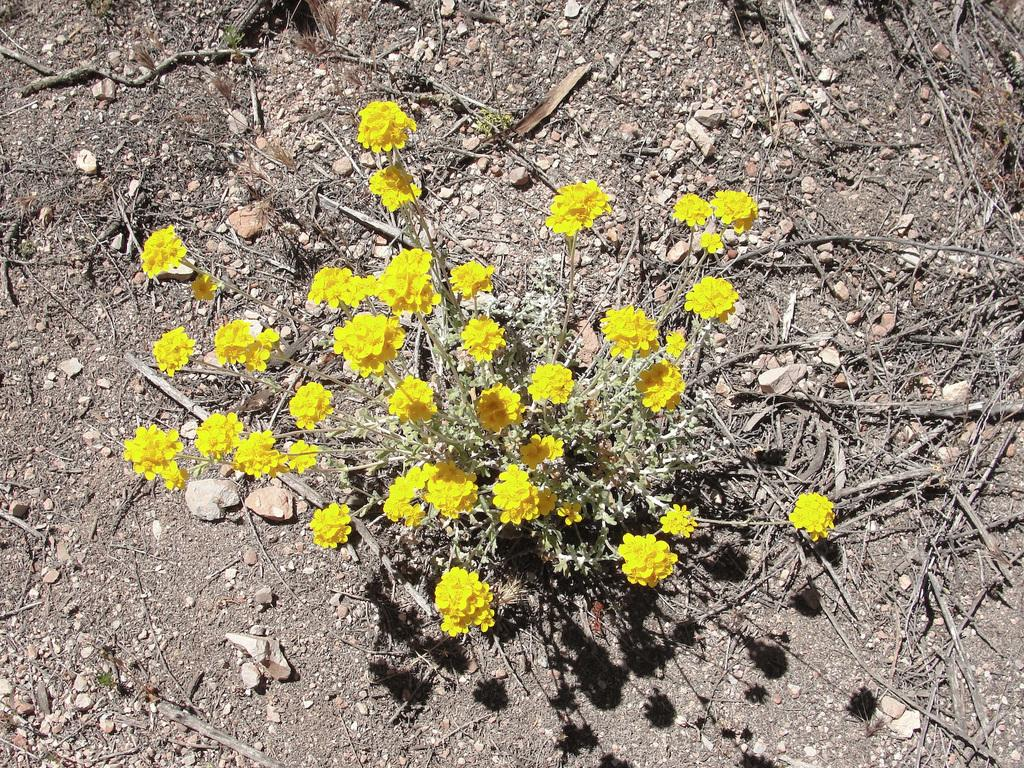What type of plant can be seen in the image? There is a yellow flower plant in the image. What else is present in the image besides the plant? There are branches and rocks in the image. What type of wine is being served in the image? There is no wine present in the image; it features a yellow flower plant, branches, and rocks. Can you see the father in the image? There is no person, including a father, present in the image. 